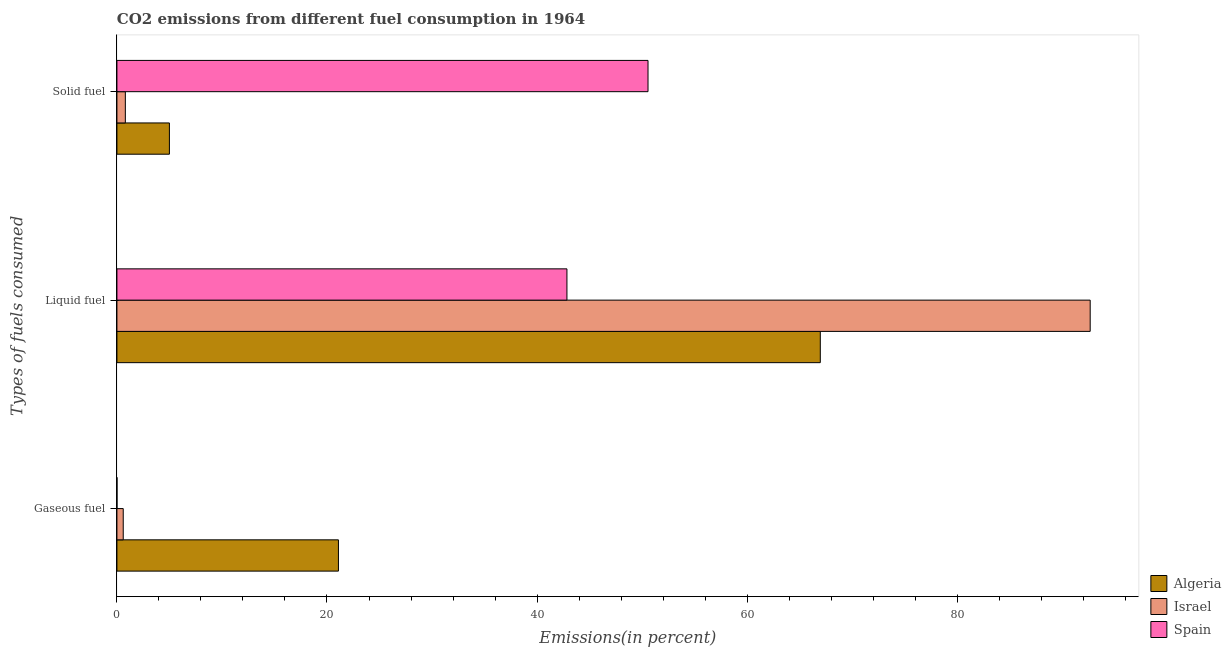How many different coloured bars are there?
Your response must be concise. 3. How many groups of bars are there?
Your answer should be compact. 3. Are the number of bars on each tick of the Y-axis equal?
Ensure brevity in your answer.  Yes. How many bars are there on the 2nd tick from the bottom?
Provide a succinct answer. 3. What is the label of the 2nd group of bars from the top?
Offer a terse response. Liquid fuel. What is the percentage of solid fuel emission in Algeria?
Keep it short and to the point. 5. Across all countries, what is the maximum percentage of gaseous fuel emission?
Your response must be concise. 21.09. Across all countries, what is the minimum percentage of solid fuel emission?
Make the answer very short. 0.8. In which country was the percentage of gaseous fuel emission maximum?
Offer a terse response. Algeria. In which country was the percentage of gaseous fuel emission minimum?
Keep it short and to the point. Spain. What is the total percentage of solid fuel emission in the graph?
Your answer should be compact. 56.36. What is the difference between the percentage of solid fuel emission in Algeria and that in Israel?
Keep it short and to the point. 4.2. What is the difference between the percentage of solid fuel emission in Israel and the percentage of liquid fuel emission in Spain?
Your answer should be compact. -42.04. What is the average percentage of solid fuel emission per country?
Ensure brevity in your answer.  18.79. What is the difference between the percentage of liquid fuel emission and percentage of gaseous fuel emission in Algeria?
Ensure brevity in your answer.  45.88. What is the ratio of the percentage of gaseous fuel emission in Israel to that in Spain?
Offer a terse response. 105.6. Is the difference between the percentage of solid fuel emission in Algeria and Spain greater than the difference between the percentage of gaseous fuel emission in Algeria and Spain?
Offer a terse response. No. What is the difference between the highest and the second highest percentage of liquid fuel emission?
Provide a short and direct response. 25.7. What is the difference between the highest and the lowest percentage of gaseous fuel emission?
Provide a short and direct response. 21.08. Is the sum of the percentage of liquid fuel emission in Israel and Spain greater than the maximum percentage of gaseous fuel emission across all countries?
Ensure brevity in your answer.  Yes. What does the 3rd bar from the top in Gaseous fuel represents?
Offer a terse response. Algeria. What does the 1st bar from the bottom in Solid fuel represents?
Provide a succinct answer. Algeria. Are all the bars in the graph horizontal?
Offer a very short reply. Yes. How many countries are there in the graph?
Your answer should be compact. 3. Are the values on the major ticks of X-axis written in scientific E-notation?
Keep it short and to the point. No. Does the graph contain any zero values?
Provide a succinct answer. No. Does the graph contain grids?
Provide a short and direct response. No. Where does the legend appear in the graph?
Provide a succinct answer. Bottom right. How many legend labels are there?
Give a very brief answer. 3. How are the legend labels stacked?
Keep it short and to the point. Vertical. What is the title of the graph?
Your answer should be very brief. CO2 emissions from different fuel consumption in 1964. Does "Kenya" appear as one of the legend labels in the graph?
Provide a succinct answer. No. What is the label or title of the X-axis?
Give a very brief answer. Emissions(in percent). What is the label or title of the Y-axis?
Keep it short and to the point. Types of fuels consumed. What is the Emissions(in percent) of Algeria in Gaseous fuel?
Keep it short and to the point. 21.09. What is the Emissions(in percent) in Israel in Gaseous fuel?
Your response must be concise. 0.6. What is the Emissions(in percent) in Spain in Gaseous fuel?
Give a very brief answer. 0.01. What is the Emissions(in percent) of Algeria in Liquid fuel?
Your response must be concise. 66.97. What is the Emissions(in percent) of Israel in Liquid fuel?
Offer a very short reply. 92.67. What is the Emissions(in percent) of Spain in Liquid fuel?
Make the answer very short. 42.85. What is the Emissions(in percent) in Algeria in Solid fuel?
Give a very brief answer. 5. What is the Emissions(in percent) of Israel in Solid fuel?
Provide a short and direct response. 0.8. What is the Emissions(in percent) in Spain in Solid fuel?
Your response must be concise. 50.57. Across all Types of fuels consumed, what is the maximum Emissions(in percent) in Algeria?
Your answer should be compact. 66.97. Across all Types of fuels consumed, what is the maximum Emissions(in percent) in Israel?
Your answer should be very brief. 92.67. Across all Types of fuels consumed, what is the maximum Emissions(in percent) of Spain?
Your answer should be very brief. 50.57. Across all Types of fuels consumed, what is the minimum Emissions(in percent) in Algeria?
Offer a very short reply. 5. Across all Types of fuels consumed, what is the minimum Emissions(in percent) in Israel?
Make the answer very short. 0.6. Across all Types of fuels consumed, what is the minimum Emissions(in percent) in Spain?
Make the answer very short. 0.01. What is the total Emissions(in percent) of Algeria in the graph?
Your response must be concise. 93.06. What is the total Emissions(in percent) of Israel in the graph?
Keep it short and to the point. 94.07. What is the total Emissions(in percent) in Spain in the graph?
Ensure brevity in your answer.  93.42. What is the difference between the Emissions(in percent) in Algeria in Gaseous fuel and that in Liquid fuel?
Ensure brevity in your answer.  -45.88. What is the difference between the Emissions(in percent) in Israel in Gaseous fuel and that in Liquid fuel?
Keep it short and to the point. -92.06. What is the difference between the Emissions(in percent) in Spain in Gaseous fuel and that in Liquid fuel?
Make the answer very short. -42.84. What is the difference between the Emissions(in percent) in Algeria in Gaseous fuel and that in Solid fuel?
Offer a very short reply. 16.09. What is the difference between the Emissions(in percent) of Israel in Gaseous fuel and that in Solid fuel?
Provide a short and direct response. -0.2. What is the difference between the Emissions(in percent) of Spain in Gaseous fuel and that in Solid fuel?
Provide a short and direct response. -50.56. What is the difference between the Emissions(in percent) in Algeria in Liquid fuel and that in Solid fuel?
Your response must be concise. 61.97. What is the difference between the Emissions(in percent) in Israel in Liquid fuel and that in Solid fuel?
Provide a succinct answer. 91.86. What is the difference between the Emissions(in percent) in Spain in Liquid fuel and that in Solid fuel?
Offer a very short reply. -7.72. What is the difference between the Emissions(in percent) of Algeria in Gaseous fuel and the Emissions(in percent) of Israel in Liquid fuel?
Give a very brief answer. -71.58. What is the difference between the Emissions(in percent) in Algeria in Gaseous fuel and the Emissions(in percent) in Spain in Liquid fuel?
Offer a very short reply. -21.76. What is the difference between the Emissions(in percent) of Israel in Gaseous fuel and the Emissions(in percent) of Spain in Liquid fuel?
Give a very brief answer. -42.25. What is the difference between the Emissions(in percent) of Algeria in Gaseous fuel and the Emissions(in percent) of Israel in Solid fuel?
Make the answer very short. 20.29. What is the difference between the Emissions(in percent) in Algeria in Gaseous fuel and the Emissions(in percent) in Spain in Solid fuel?
Give a very brief answer. -29.48. What is the difference between the Emissions(in percent) in Israel in Gaseous fuel and the Emissions(in percent) in Spain in Solid fuel?
Your response must be concise. -49.97. What is the difference between the Emissions(in percent) of Algeria in Liquid fuel and the Emissions(in percent) of Israel in Solid fuel?
Provide a succinct answer. 66.17. What is the difference between the Emissions(in percent) of Algeria in Liquid fuel and the Emissions(in percent) of Spain in Solid fuel?
Offer a very short reply. 16.4. What is the difference between the Emissions(in percent) in Israel in Liquid fuel and the Emissions(in percent) in Spain in Solid fuel?
Your answer should be compact. 42.1. What is the average Emissions(in percent) in Algeria per Types of fuels consumed?
Provide a succinct answer. 31.02. What is the average Emissions(in percent) in Israel per Types of fuels consumed?
Your answer should be very brief. 31.36. What is the average Emissions(in percent) in Spain per Types of fuels consumed?
Make the answer very short. 31.14. What is the difference between the Emissions(in percent) of Algeria and Emissions(in percent) of Israel in Gaseous fuel?
Your response must be concise. 20.49. What is the difference between the Emissions(in percent) in Algeria and Emissions(in percent) in Spain in Gaseous fuel?
Give a very brief answer. 21.08. What is the difference between the Emissions(in percent) in Israel and Emissions(in percent) in Spain in Gaseous fuel?
Offer a terse response. 0.6. What is the difference between the Emissions(in percent) in Algeria and Emissions(in percent) in Israel in Liquid fuel?
Offer a very short reply. -25.7. What is the difference between the Emissions(in percent) in Algeria and Emissions(in percent) in Spain in Liquid fuel?
Keep it short and to the point. 24.12. What is the difference between the Emissions(in percent) in Israel and Emissions(in percent) in Spain in Liquid fuel?
Ensure brevity in your answer.  49.82. What is the difference between the Emissions(in percent) of Algeria and Emissions(in percent) of Israel in Solid fuel?
Ensure brevity in your answer.  4.2. What is the difference between the Emissions(in percent) of Algeria and Emissions(in percent) of Spain in Solid fuel?
Provide a succinct answer. -45.57. What is the difference between the Emissions(in percent) of Israel and Emissions(in percent) of Spain in Solid fuel?
Your answer should be compact. -49.76. What is the ratio of the Emissions(in percent) in Algeria in Gaseous fuel to that in Liquid fuel?
Offer a terse response. 0.31. What is the ratio of the Emissions(in percent) in Israel in Gaseous fuel to that in Liquid fuel?
Ensure brevity in your answer.  0.01. What is the ratio of the Emissions(in percent) in Spain in Gaseous fuel to that in Liquid fuel?
Your answer should be very brief. 0. What is the ratio of the Emissions(in percent) in Algeria in Gaseous fuel to that in Solid fuel?
Ensure brevity in your answer.  4.22. What is the ratio of the Emissions(in percent) in Israel in Gaseous fuel to that in Solid fuel?
Provide a succinct answer. 0.75. What is the ratio of the Emissions(in percent) of Spain in Gaseous fuel to that in Solid fuel?
Make the answer very short. 0. What is the ratio of the Emissions(in percent) in Algeria in Liquid fuel to that in Solid fuel?
Your answer should be very brief. 13.4. What is the ratio of the Emissions(in percent) of Israel in Liquid fuel to that in Solid fuel?
Offer a terse response. 115.6. What is the ratio of the Emissions(in percent) in Spain in Liquid fuel to that in Solid fuel?
Provide a succinct answer. 0.85. What is the difference between the highest and the second highest Emissions(in percent) of Algeria?
Your answer should be compact. 45.88. What is the difference between the highest and the second highest Emissions(in percent) in Israel?
Provide a short and direct response. 91.86. What is the difference between the highest and the second highest Emissions(in percent) in Spain?
Your answer should be compact. 7.72. What is the difference between the highest and the lowest Emissions(in percent) of Algeria?
Your answer should be very brief. 61.97. What is the difference between the highest and the lowest Emissions(in percent) of Israel?
Offer a terse response. 92.06. What is the difference between the highest and the lowest Emissions(in percent) in Spain?
Provide a short and direct response. 50.56. 